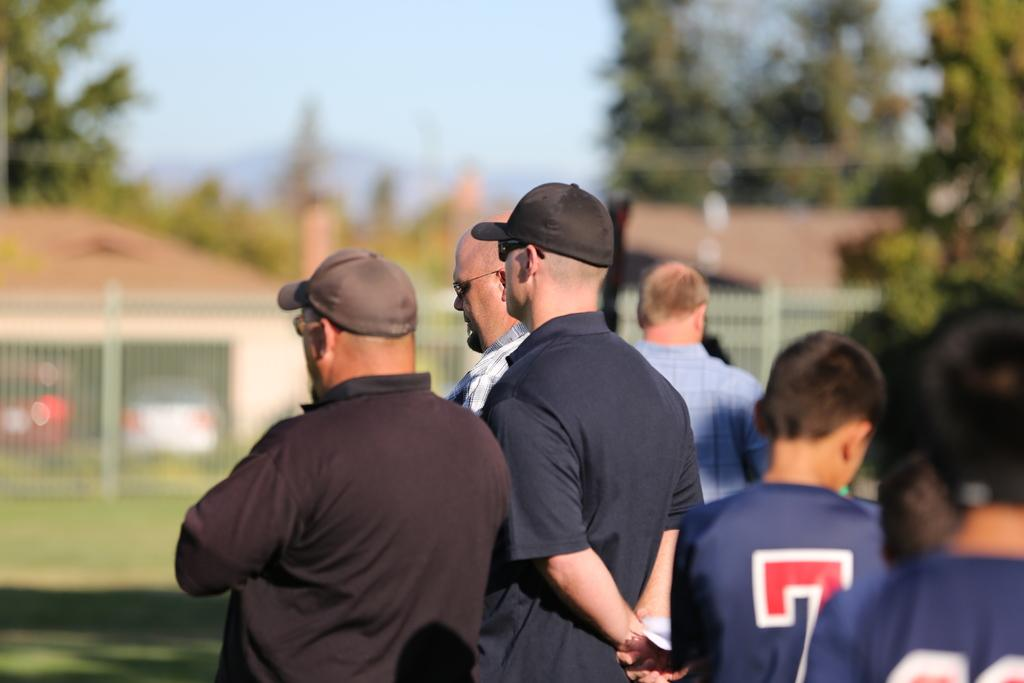What is happening in the image? There are people standing in the image. Can you describe the attire of some of the people? Some of the people are wearing caps. What can be seen in the background of the image? There is a fence, sheds, and trees visible in the background of the image. What is the level of disgust expressed by the people in the image? There is no indication of disgust in the image; the people are simply standing. 